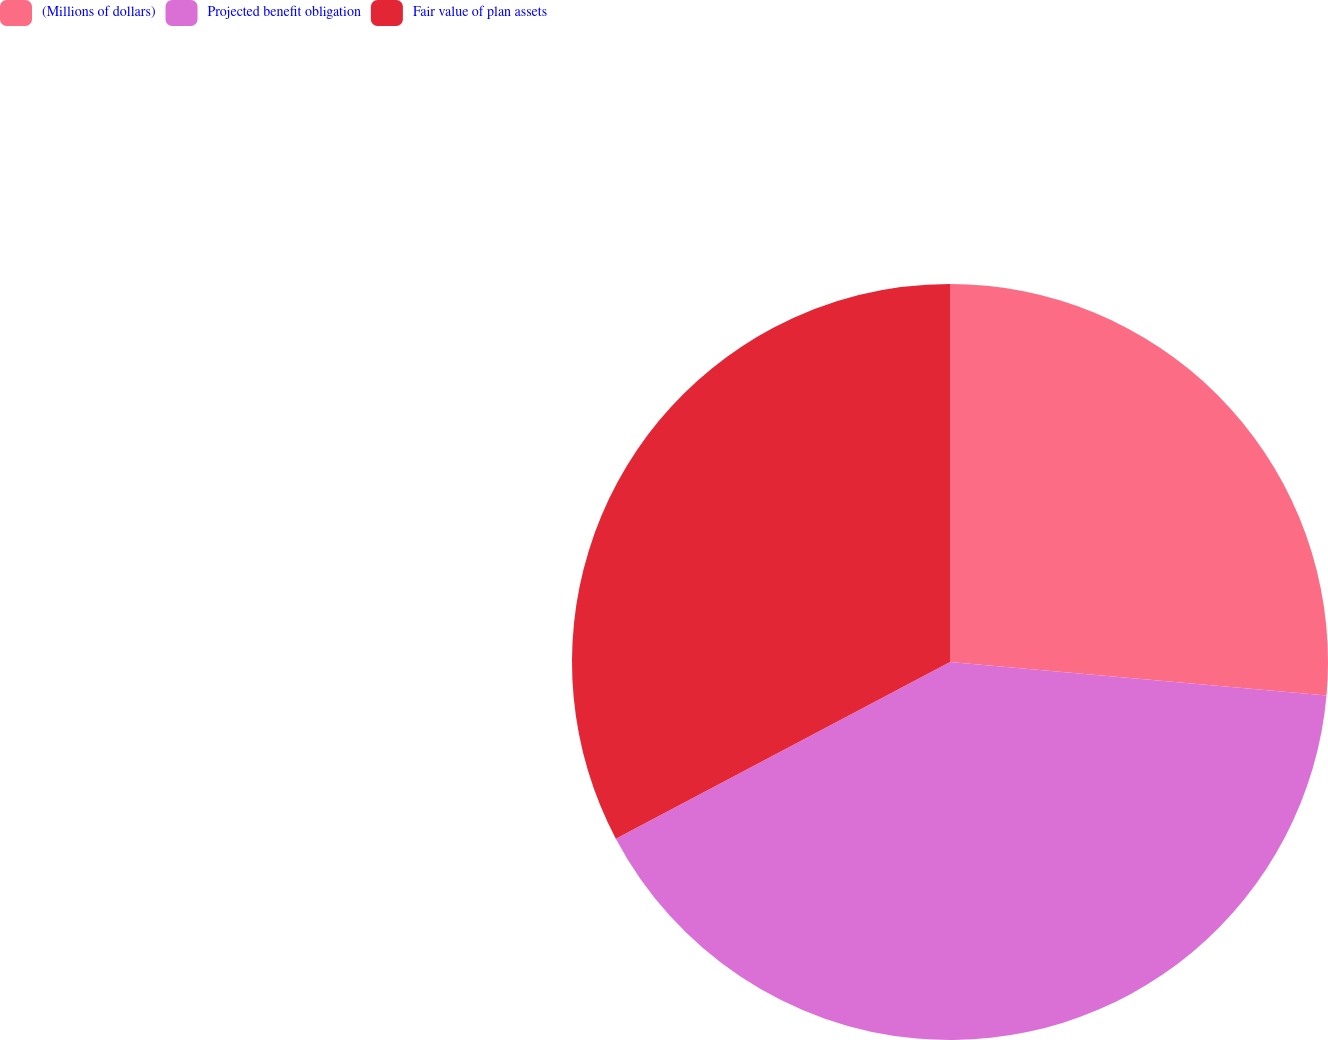Convert chart to OTSL. <chart><loc_0><loc_0><loc_500><loc_500><pie_chart><fcel>(Millions of dollars)<fcel>Projected benefit obligation<fcel>Fair value of plan assets<nl><fcel>26.41%<fcel>40.85%<fcel>32.74%<nl></chart> 